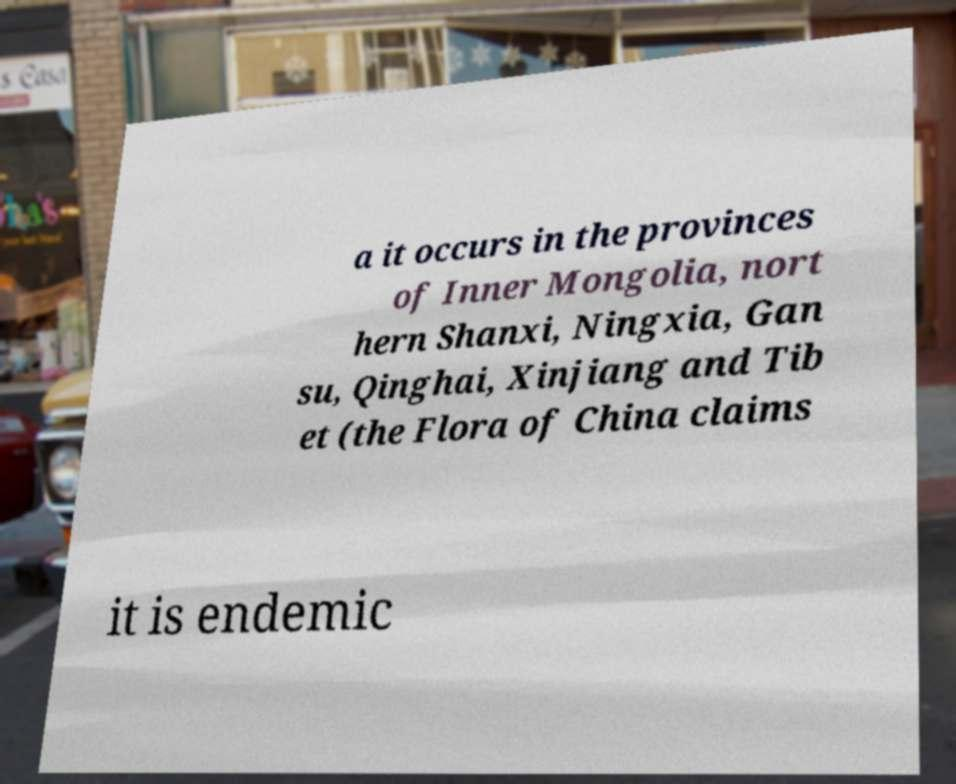Please identify and transcribe the text found in this image. a it occurs in the provinces of Inner Mongolia, nort hern Shanxi, Ningxia, Gan su, Qinghai, Xinjiang and Tib et (the Flora of China claims it is endemic 